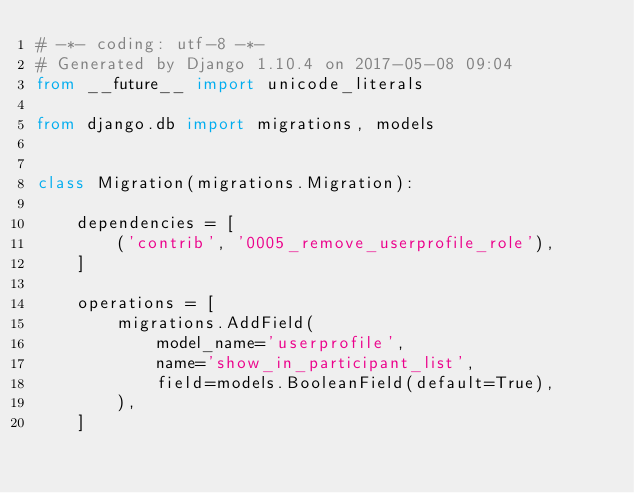Convert code to text. <code><loc_0><loc_0><loc_500><loc_500><_Python_># -*- coding: utf-8 -*-
# Generated by Django 1.10.4 on 2017-05-08 09:04
from __future__ import unicode_literals

from django.db import migrations, models


class Migration(migrations.Migration):

    dependencies = [
        ('contrib', '0005_remove_userprofile_role'),
    ]

    operations = [
        migrations.AddField(
            model_name='userprofile',
            name='show_in_participant_list',
            field=models.BooleanField(default=True),
        ),
    ]
</code> 